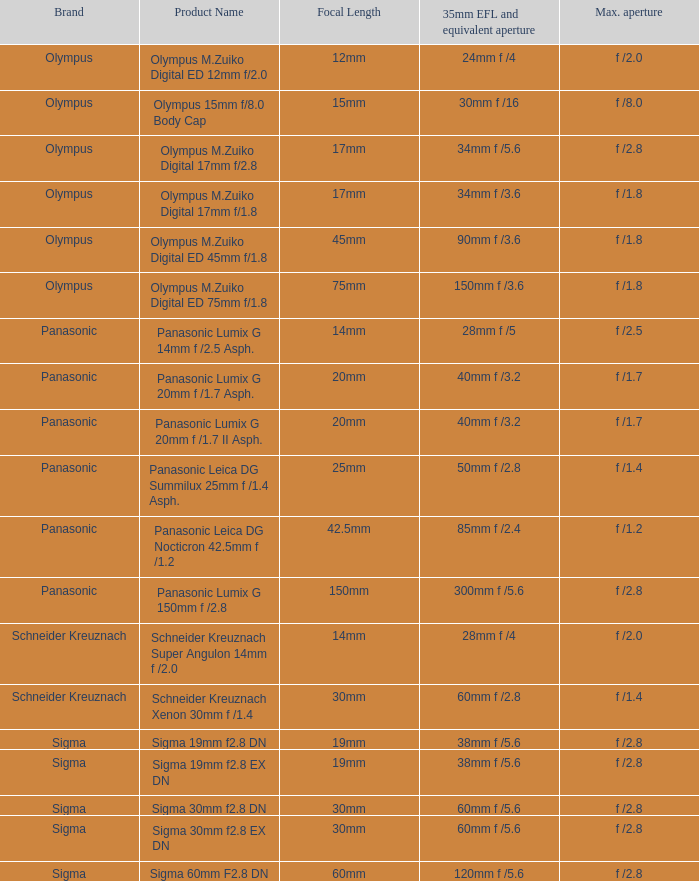What is the 35mm EFL and the equivalent aperture of the lens(es) with a maximum aperture of f /2.5? 28mm f /5. Parse the table in full. {'header': ['Brand', 'Product Name', 'Focal Length', '35mm EFL and equivalent aperture', 'Max. aperture'], 'rows': [['Olympus', 'Olympus M.Zuiko Digital ED 12mm f/2.0', '12mm', '24mm f /4', 'f /2.0'], ['Olympus', 'Olympus 15mm f/8.0 Body Cap', '15mm', '30mm f /16', 'f /8.0'], ['Olympus', 'Olympus M.Zuiko Digital 17mm f/2.8', '17mm', '34mm f /5.6', 'f /2.8'], ['Olympus', 'Olympus M.Zuiko Digital 17mm f/1.8', '17mm', '34mm f /3.6', 'f /1.8'], ['Olympus', 'Olympus M.Zuiko Digital ED 45mm f/1.8', '45mm', '90mm f /3.6', 'f /1.8'], ['Olympus', 'Olympus M.Zuiko Digital ED 75mm f/1.8', '75mm', '150mm f /3.6', 'f /1.8'], ['Panasonic', 'Panasonic Lumix G 14mm f /2.5 Asph.', '14mm', '28mm f /5', 'f /2.5'], ['Panasonic', 'Panasonic Lumix G 20mm f /1.7 Asph.', '20mm', '40mm f /3.2', 'f /1.7'], ['Panasonic', 'Panasonic Lumix G 20mm f /1.7 II Asph.', '20mm', '40mm f /3.2', 'f /1.7'], ['Panasonic', 'Panasonic Leica DG Summilux 25mm f /1.4 Asph.', '25mm', '50mm f /2.8', 'f /1.4'], ['Panasonic', 'Panasonic Leica DG Nocticron 42.5mm f /1.2', '42.5mm', '85mm f /2.4', 'f /1.2'], ['Panasonic', 'Panasonic Lumix G 150mm f /2.8', '150mm', '300mm f /5.6', 'f /2.8'], ['Schneider Kreuznach', 'Schneider Kreuznach Super Angulon 14mm f /2.0', '14mm', '28mm f /4', 'f /2.0'], ['Schneider Kreuznach', 'Schneider Kreuznach Xenon 30mm f /1.4', '30mm', '60mm f /2.8', 'f /1.4'], ['Sigma', 'Sigma 19mm f2.8 DN', '19mm', '38mm f /5.6', 'f /2.8'], ['Sigma', 'Sigma 19mm f2.8 EX DN', '19mm', '38mm f /5.6', 'f /2.8'], ['Sigma', 'Sigma 30mm f2.8 DN', '30mm', '60mm f /5.6', 'f /2.8'], ['Sigma', 'Sigma 30mm f2.8 EX DN', '30mm', '60mm f /5.6', 'f /2.8'], ['Sigma', 'Sigma 60mm F2.8 DN', '60mm', '120mm f /5.6', 'f /2.8']]} 